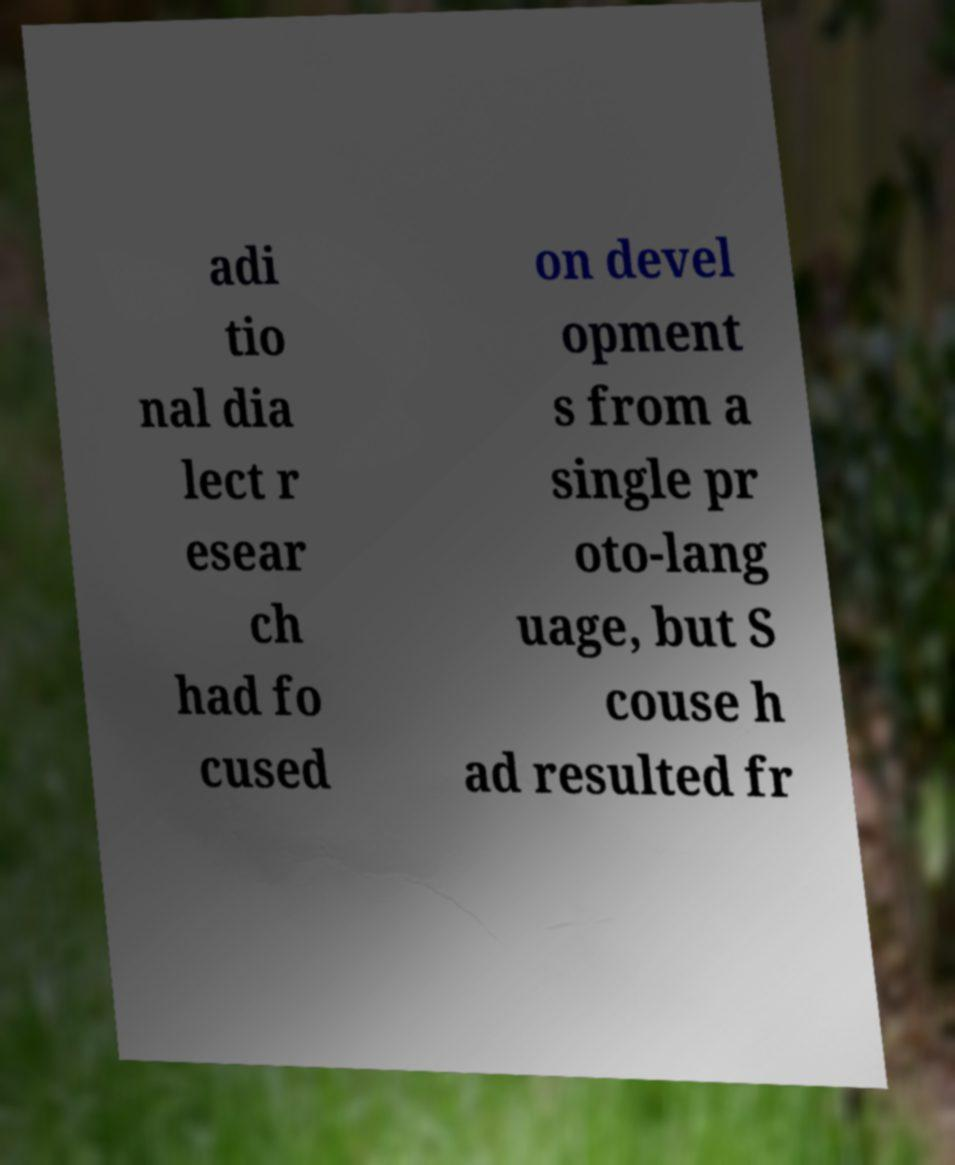Please read and relay the text visible in this image. What does it say? adi tio nal dia lect r esear ch had fo cused on devel opment s from a single pr oto-lang uage, but S couse h ad resulted fr 